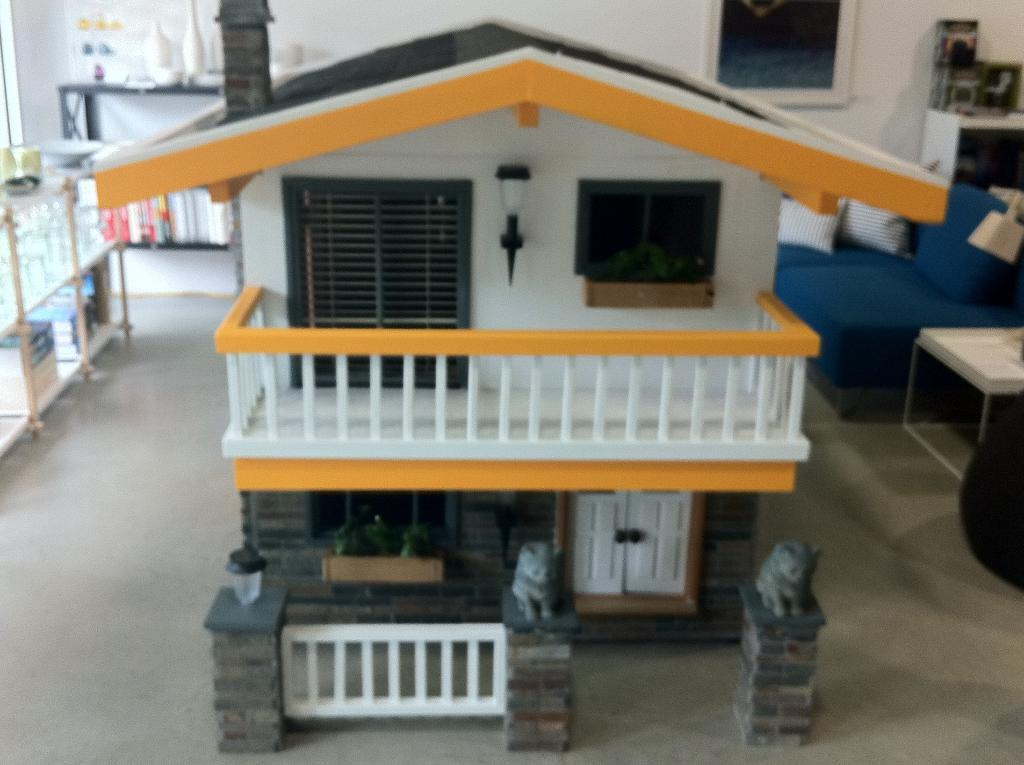What is the main subject in the middle of the picture? There is a scale model of a house in the middle of the picture. What type of furniture is on the right side of the picture? There is a sofa on the right side of the picture. What can be seen in the background of the picture? There is a wall in the background of the picture. How does the scale model of the house connect to the wall in the background? The scale model of the house does not connect to the wall in the background; it is a separate object in the image. 